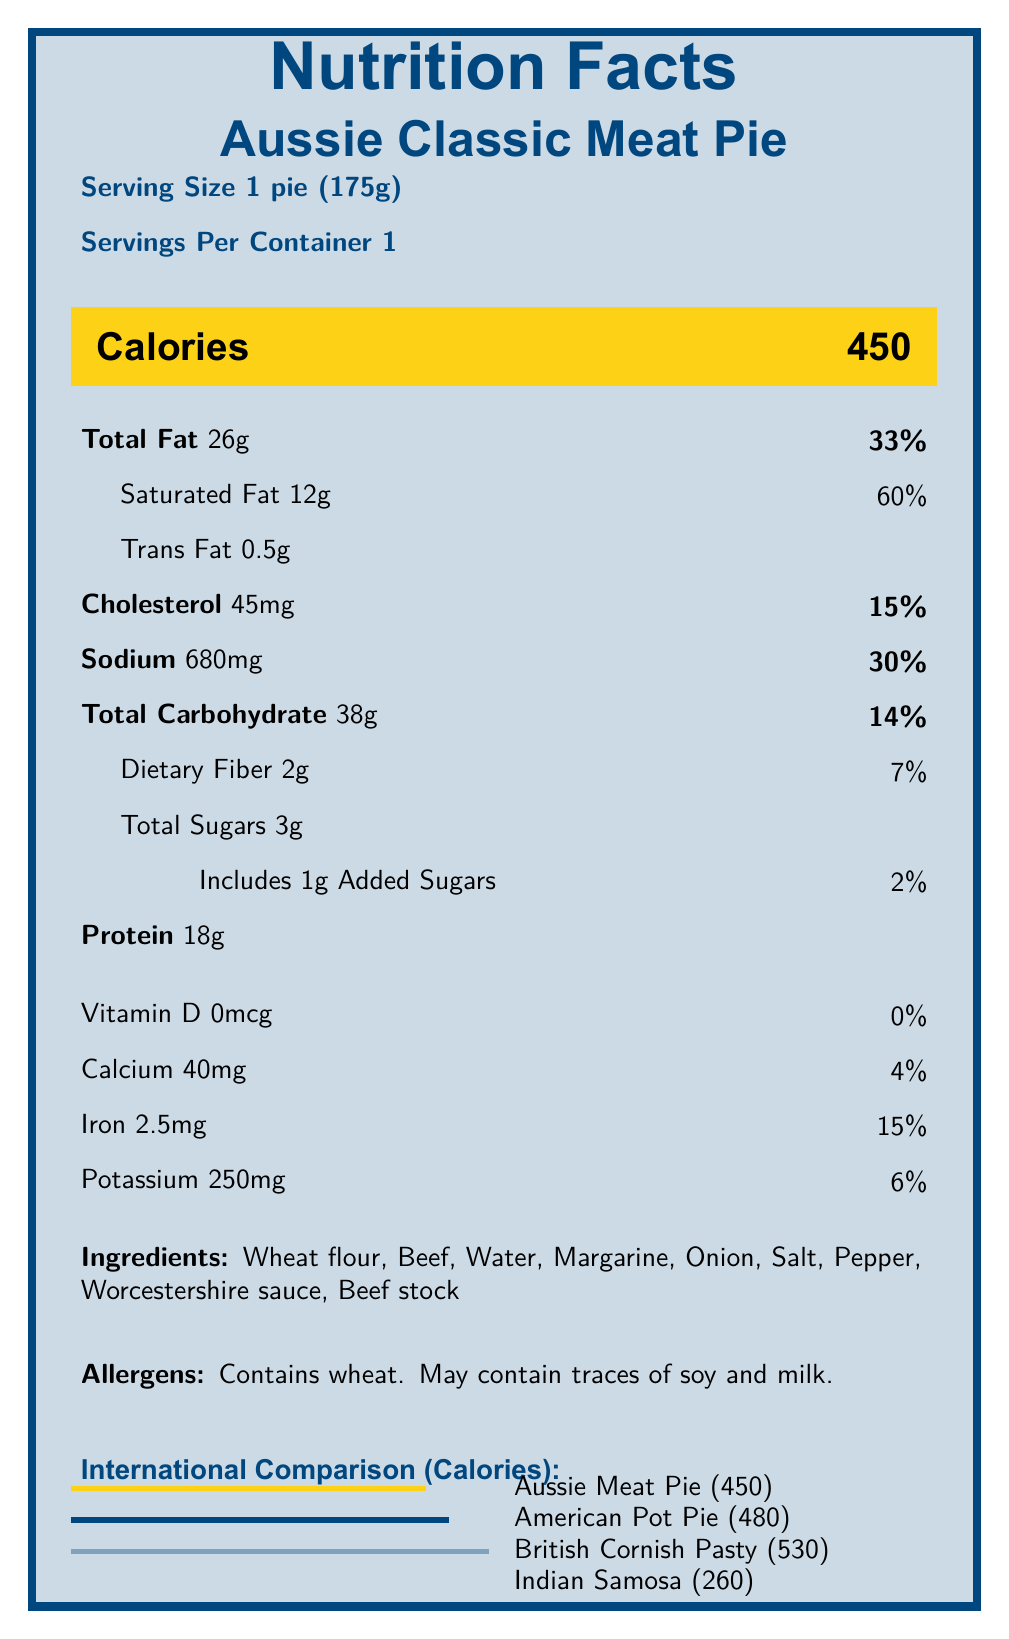What is the serving size of the Aussie Classic Meat Pie? The document specifies that the serving size is "1 pie (175g)".
Answer: 1 pie (175g) How many calories are in a serving of the Aussie Classic Meat Pie? The document lists "Calories" as 450 for one serving of the Aussie Classic Meat Pie.
Answer: 450 What percentage of the daily value for sodium does the Aussie Classic Meat Pie provide? The document states that the sodium content is 680mg, which equals 30% of the daily value.
Answer: 30% Which international food item has the highest calorie content compared to the Aussie Classic Meat Pie? The document shows that the British Cornish Pasty has 530 calories, which is the highest among the listed international foods.
Answer: British Cornish Pasty Does the Aussie Classic Meat Pie contain any vitamins? The document indicates that there is 0mcg of Vitamin D or other vitamins in the Aussie Classic Meat Pie.
Answer: No Which of the following is an ingredient in the Aussie Classic Meat Pie? A. Chicken B. Beef C. Pork D. Fish The ingredients list includes beef as one of the main components.
Answer: B. Beef How much protein does the Indian Samosa contain according to the international comparison? A. 6g B. 16g C. 18g D. 15g The international comparison section mentions that the Indian Samosa contains 6g of protein.
Answer: A. 6g Does the Aussie Classic Meat Pie contain any soy? The document states that the pie "may contain traces of soy and milk", indicating a possibility but not a certainty.
Answer: Maybe Summarize the document's main idea. The detailed explanation and breakdown show specific nutritional information, offer a comparison to international foods, and give advice and availability details at Holmesglen.
Answer: The document provides detailed nutrition facts for the Aussie Classic Meat Pie, including its ingredients, allergens, and a comparison with similar international foods. It also includes a note from a nutritionist advising moderate consumption and provides information about its availability and price at the Holmesglen cafeteria. What is the price of the Aussie Classic Meat Pie at Holmesglen cafeteria? The document mentions that the price of the Aussie Classic Meat Pie at the Holmesglen cafeteria is AUD 4.50.
Answer: AUD 4.50 How much iron does the Aussie Classic Meat Pie provide as a percentage of the daily value? The document specifies the iron content as 2.5mg, which equals 15% of the daily value.
Answer: 15% Which pie has the lowest total fat content? The international comparison shows the Indian Samosa has 14g of total fat, which is the lowest among the items listed.
Answer: Indian Samosa Can the calorie content of a Mexican Empanada be found in the document? The document contains calorie comparisons with an American Pot Pie, British Cornish Pasty, and Indian Samosa but does not mention a Mexican Empanada.
Answer: Not enough information What additional nutrient does the nutritionist suggest pairing the meat pie with? The nutritionist notes that students should pair the meat pie with a side salad or vegetables for additional nutrients.
Answer: Vegetables or a side salad 